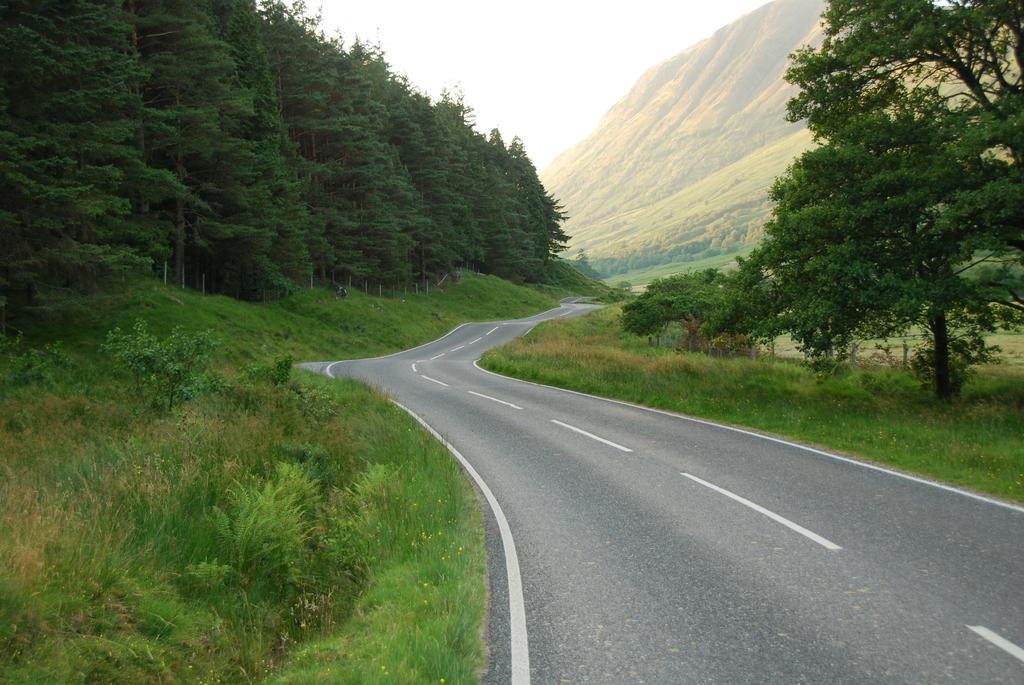What is the main feature of the image? There is a road in the image. What can be seen on both sides of the road? There are trees on either side of the road. What type of vegetation is visible in the image? Grass is visible in the image. What can be seen in the distance in the image? There are hills in the background of the image. What is visible above the hills in the image? The sky is visible in the background of the image. How many points does the umbrella have in the image? There is no umbrella present in the image. Can you describe the kiss between the two people in the image? There are no people or kisses depicted in the image. 